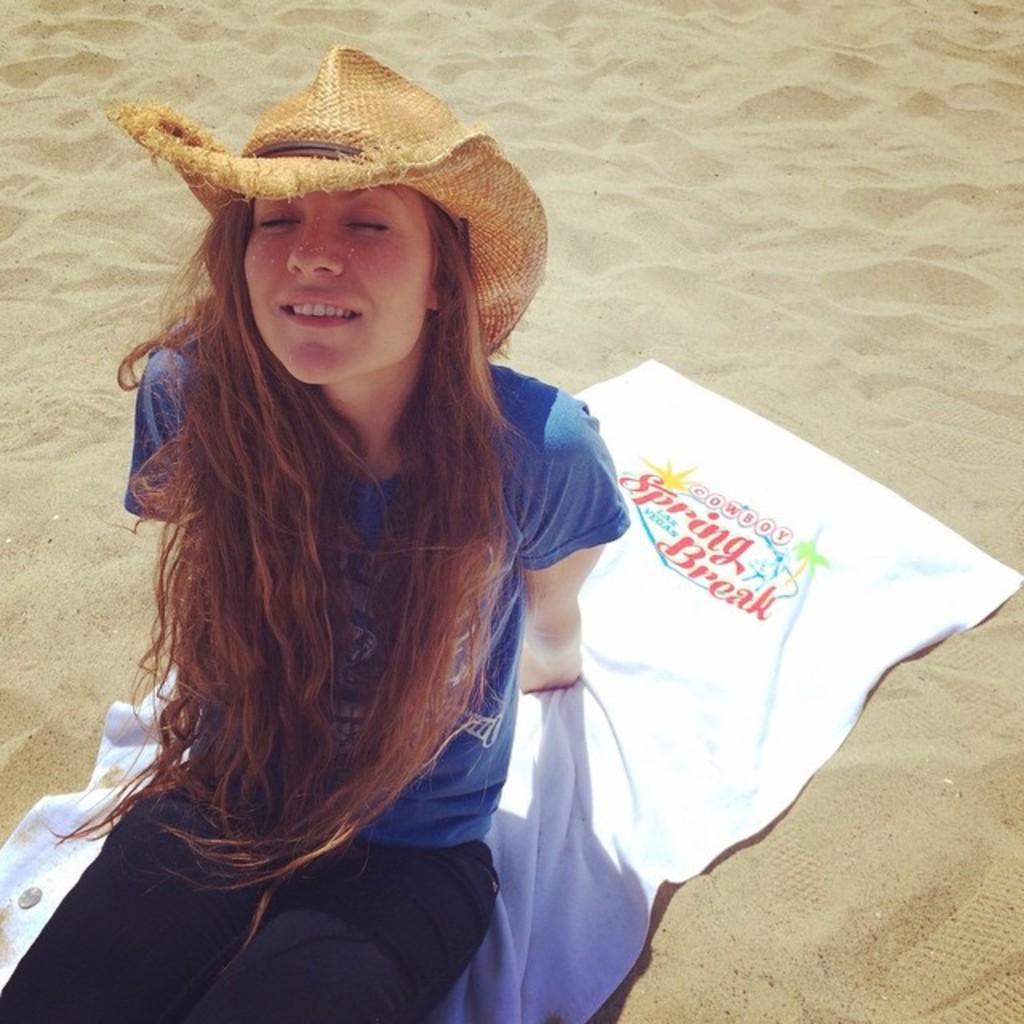Please provide a concise description of this image. In this picture we can see a woman, she wore a cap and she is seated on the towel, also we can see sand. 